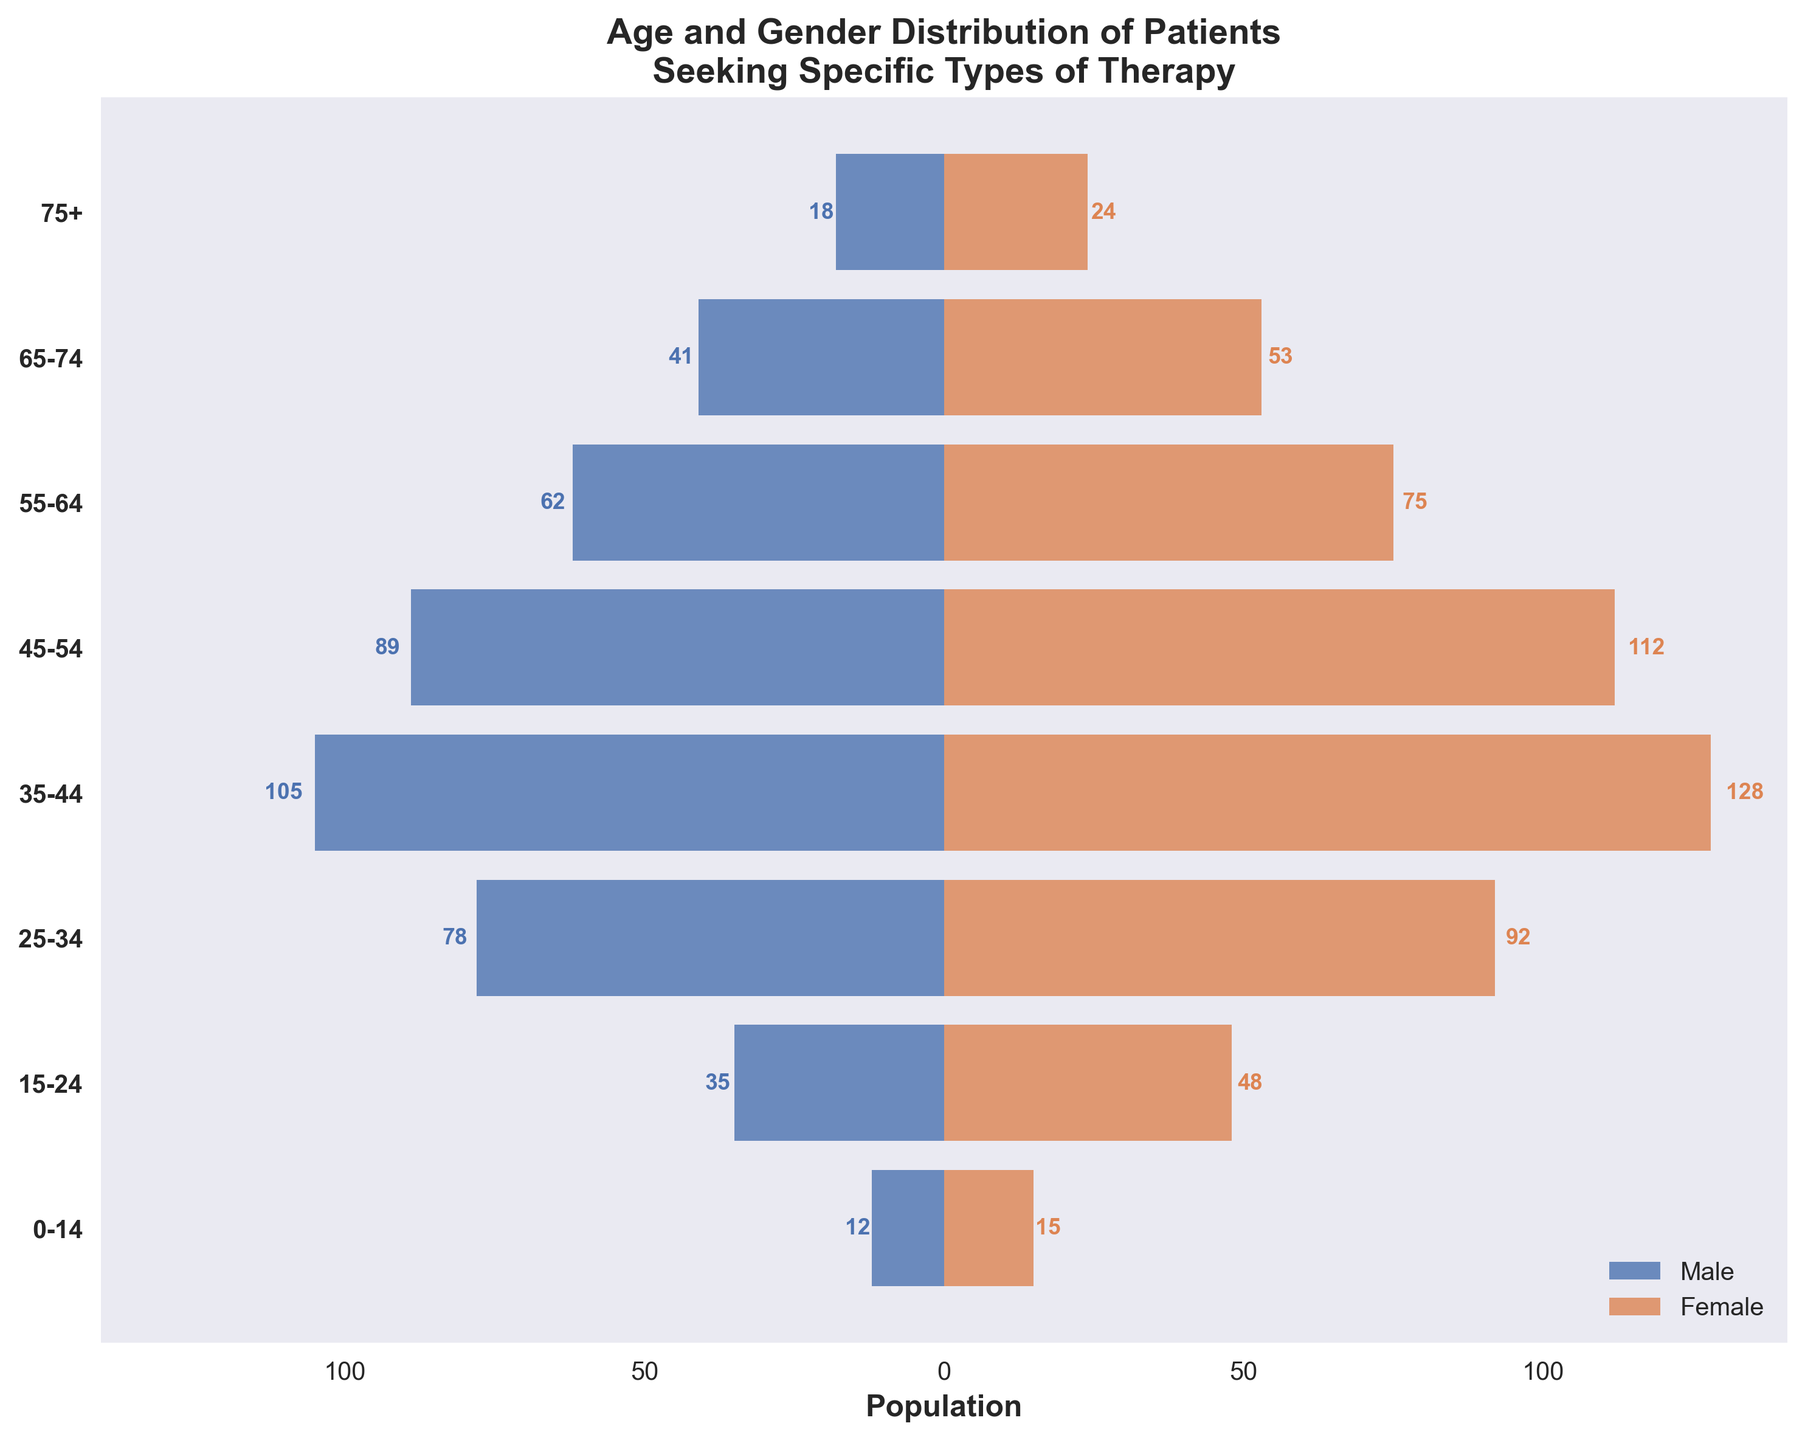What's the title of the figure? The title is usually written at the top of the figure in a slightly larger font size than the other text to grab the viewer's attention. The title helps to understand what the figure represents.
Answer: Age and Gender Distribution of Patients Seeking Specific Types of Therapy How many age groups are represented in the figure? By counting the different horizontal bars or labels on the vertical axis, one can determine the number of age groups presented in the figure.
Answer: 8 Which age group has the highest number of female patients? Look at the bar representing female patients (in the color assigned to females) and find the longest bar. The label corresponding to this bar indicates the age group.
Answer: 35-44 What's the combined number of male and female patients in the 55-64 age group? First, find the number of male and female patients in the 55-64 age group by looking at the respective bars. Sum these two values to get the combined number.
Answer: 62 + 75 = 137 Is the number of male patients in the 45-54 age group greater than the number of female patients in the 25-34 age group? Compare the length of the bar representing male patients in the 45-54 age group with the length of the bar representing female patients in the 25-34 age group.
Answer: No What is the difference between the number of female patients and male patients in the 35-44 age group? Identify the number of female patients and male patients in the 35-44 age group. Subtract the male count from the female count to find the difference.
Answer: 128 - 105 = 23 In which age group is the patient gender distribution (number of male patients vs. female patients) closest to being equal? Compare the bar lengths for each age group and identify where the lengths of the male and female bars are most similar.
Answer: 75+ What's the total number of patients in the 25-34 age group? Add the number of male and female patients in the 25-34 age group to find the total number of patients.
Answer: 78 + 92 = 170 Do the male patients or female patients in the 15-24 age group have a greater proportion compared to other age groups? Compare the lengths of the bars across all age groups. Determine if the length of the bar for male or female patients in the 15-24 age group is relatively larger compared to their corresponding bars in other groups.
Answer: Female patients Which gender showed a more significant increase in the number of patients from the 0-14 age group to the 15-24 age group? Check the difference in the bar lengths for males and females between the 0-14 and 15-24 age groups to see which had a greater increase.
Answer: Female 